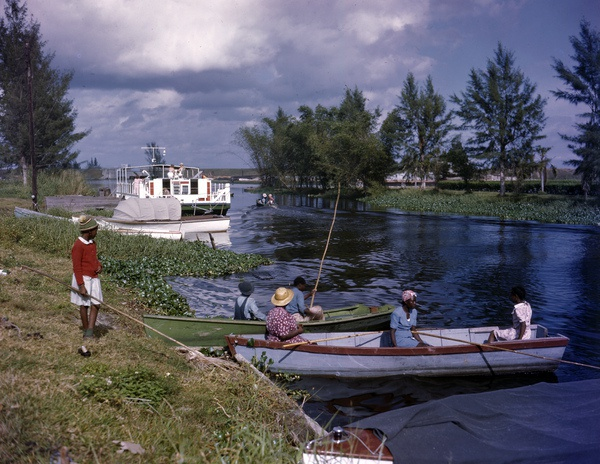Describe the objects in this image and their specific colors. I can see boat in gray, navy, black, and maroon tones, boat in gray and black tones, boat in gray, white, darkgray, and black tones, boat in gray, darkgreen, and black tones, and boat in gray, lightgray, and darkgray tones in this image. 